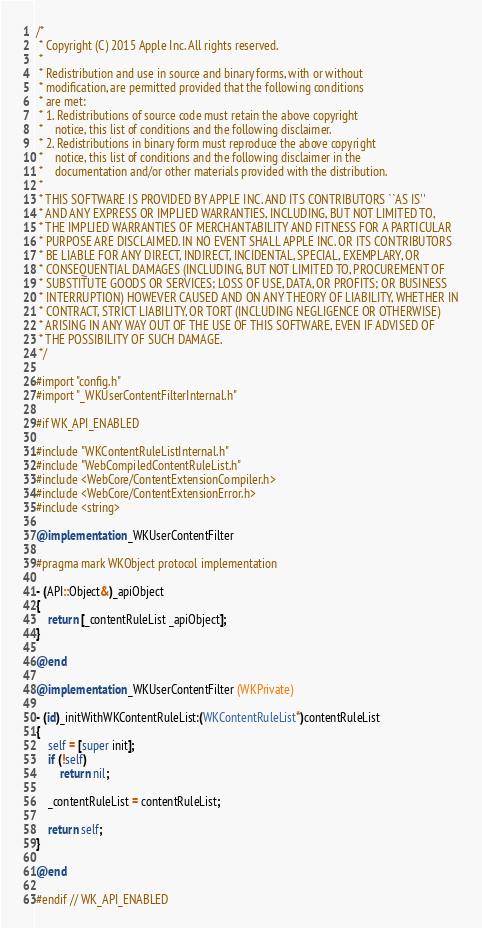<code> <loc_0><loc_0><loc_500><loc_500><_ObjectiveC_>/*
 * Copyright (C) 2015 Apple Inc. All rights reserved.
 *
 * Redistribution and use in source and binary forms, with or without
 * modification, are permitted provided that the following conditions
 * are met:
 * 1. Redistributions of source code must retain the above copyright
 *    notice, this list of conditions and the following disclaimer.
 * 2. Redistributions in binary form must reproduce the above copyright
 *    notice, this list of conditions and the following disclaimer in the
 *    documentation and/or other materials provided with the distribution.
 *
 * THIS SOFTWARE IS PROVIDED BY APPLE INC. AND ITS CONTRIBUTORS ``AS IS''
 * AND ANY EXPRESS OR IMPLIED WARRANTIES, INCLUDING, BUT NOT LIMITED TO,
 * THE IMPLIED WARRANTIES OF MERCHANTABILITY AND FITNESS FOR A PARTICULAR
 * PURPOSE ARE DISCLAIMED. IN NO EVENT SHALL APPLE INC. OR ITS CONTRIBUTORS
 * BE LIABLE FOR ANY DIRECT, INDIRECT, INCIDENTAL, SPECIAL, EXEMPLARY, OR
 * CONSEQUENTIAL DAMAGES (INCLUDING, BUT NOT LIMITED TO, PROCUREMENT OF
 * SUBSTITUTE GOODS OR SERVICES; LOSS OF USE, DATA, OR PROFITS; OR BUSINESS
 * INTERRUPTION) HOWEVER CAUSED AND ON ANY THEORY OF LIABILITY, WHETHER IN
 * CONTRACT, STRICT LIABILITY, OR TORT (INCLUDING NEGLIGENCE OR OTHERWISE)
 * ARISING IN ANY WAY OUT OF THE USE OF THIS SOFTWARE, EVEN IF ADVISED OF
 * THE POSSIBILITY OF SUCH DAMAGE.
 */

#import "config.h"
#import "_WKUserContentFilterInternal.h"

#if WK_API_ENABLED

#include "WKContentRuleListInternal.h"
#include "WebCompiledContentRuleList.h"
#include <WebCore/ContentExtensionCompiler.h>
#include <WebCore/ContentExtensionError.h>
#include <string>

@implementation _WKUserContentFilter

#pragma mark WKObject protocol implementation

- (API::Object&)_apiObject
{
    return [_contentRuleList _apiObject];
}

@end

@implementation _WKUserContentFilter (WKPrivate)

- (id)_initWithWKContentRuleList:(WKContentRuleList*)contentRuleList
{
    self = [super init];
    if (!self)
        return nil;
    
    _contentRuleList = contentRuleList;
    
    return self;
}

@end

#endif // WK_API_ENABLED
</code> 